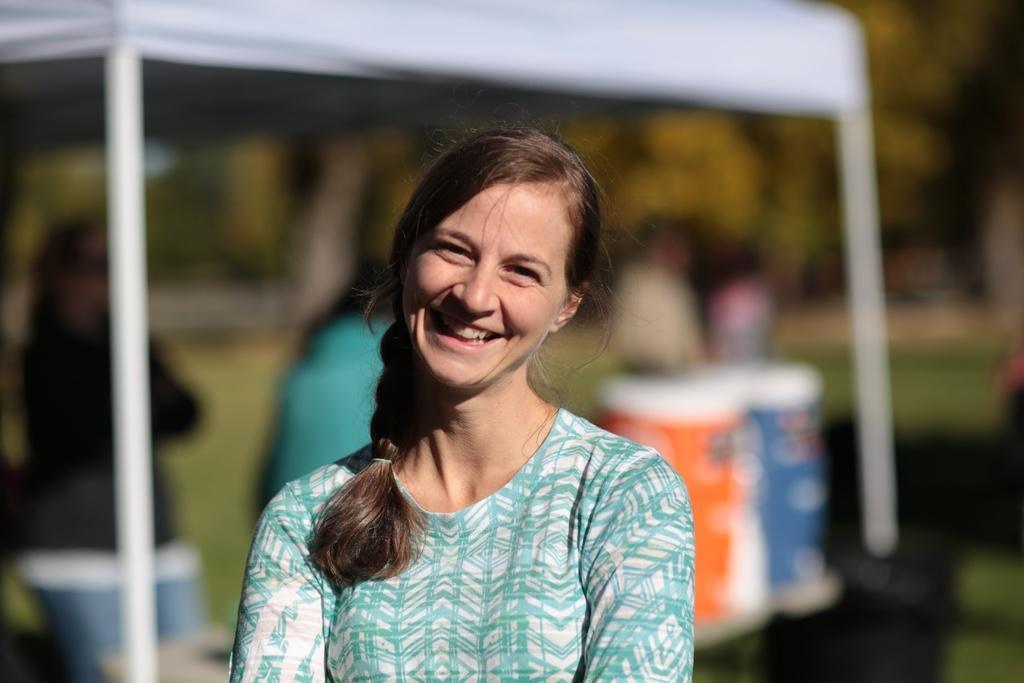Could you give a brief overview of what you see in this image? This picture is clicked outside. In the foreground there is a woman smiling and standing. The background of the image is blur and we can see the group of people and some objects under the tent and we can see the trees and some other objects. 